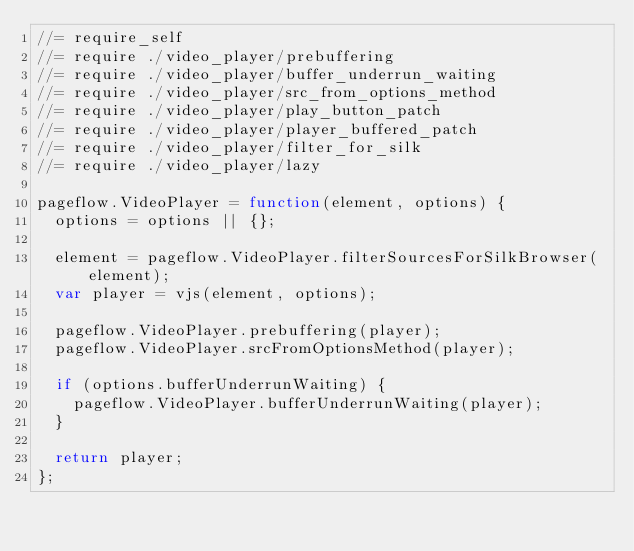Convert code to text. <code><loc_0><loc_0><loc_500><loc_500><_JavaScript_>//= require_self
//= require ./video_player/prebuffering
//= require ./video_player/buffer_underrun_waiting
//= require ./video_player/src_from_options_method
//= require ./video_player/play_button_patch
//= require ./video_player/player_buffered_patch
//= require ./video_player/filter_for_silk
//= require ./video_player/lazy

pageflow.VideoPlayer = function(element, options) {
  options = options || {};

  element = pageflow.VideoPlayer.filterSourcesForSilkBrowser(element);
  var player = vjs(element, options);

  pageflow.VideoPlayer.prebuffering(player);
  pageflow.VideoPlayer.srcFromOptionsMethod(player);

  if (options.bufferUnderrunWaiting) {
    pageflow.VideoPlayer.bufferUnderrunWaiting(player);
  }

  return player;
};</code> 